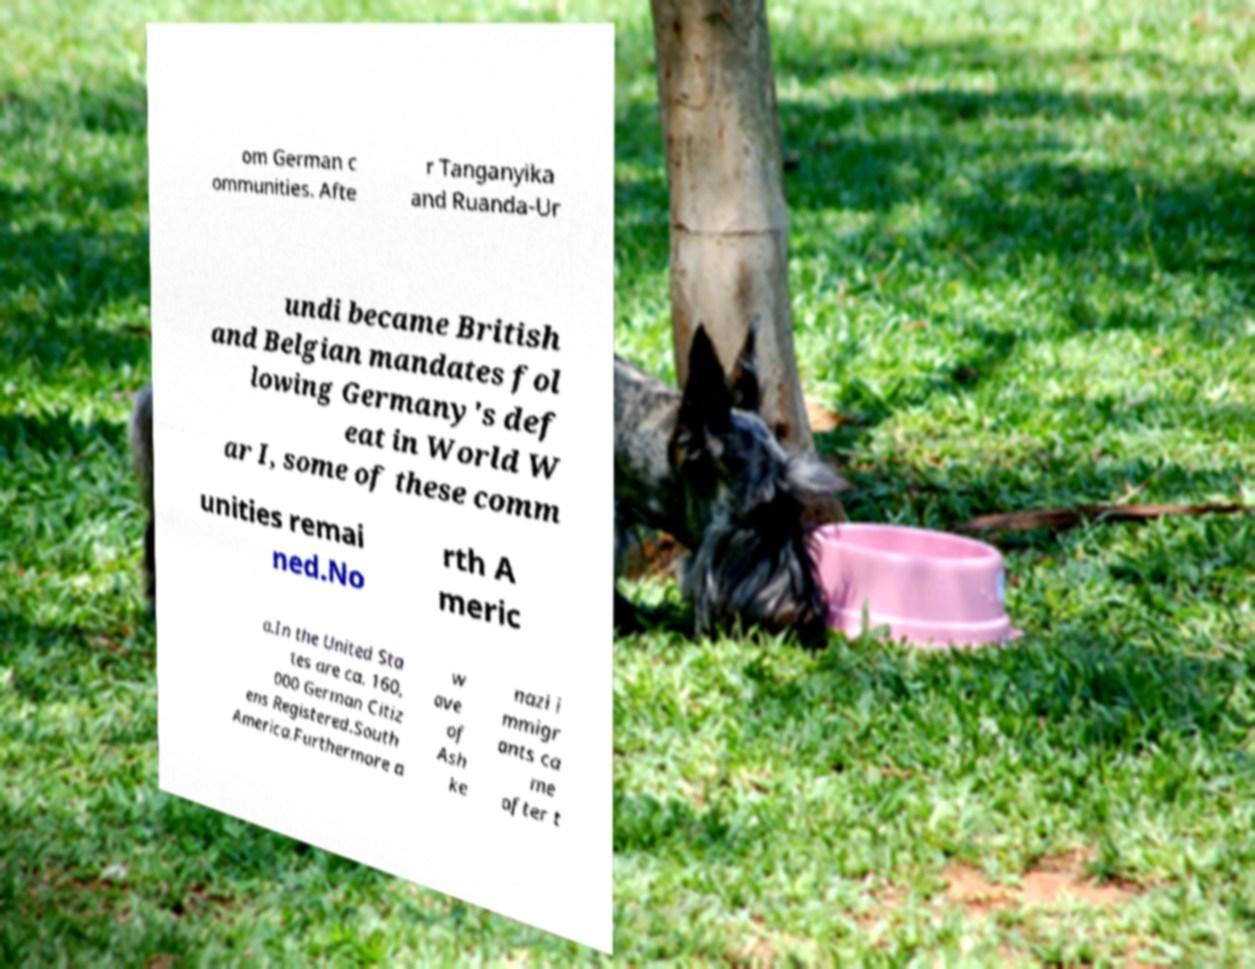There's text embedded in this image that I need extracted. Can you transcribe it verbatim? om German c ommunities. Afte r Tanganyika and Ruanda-Ur undi became British and Belgian mandates fol lowing Germany's def eat in World W ar I, some of these comm unities remai ned.No rth A meric a.In the United Sta tes are ca. 160, 000 German Citiz ens Registered.South America.Furthermore a w ave of Ash ke nazi i mmigr ants ca me after t 